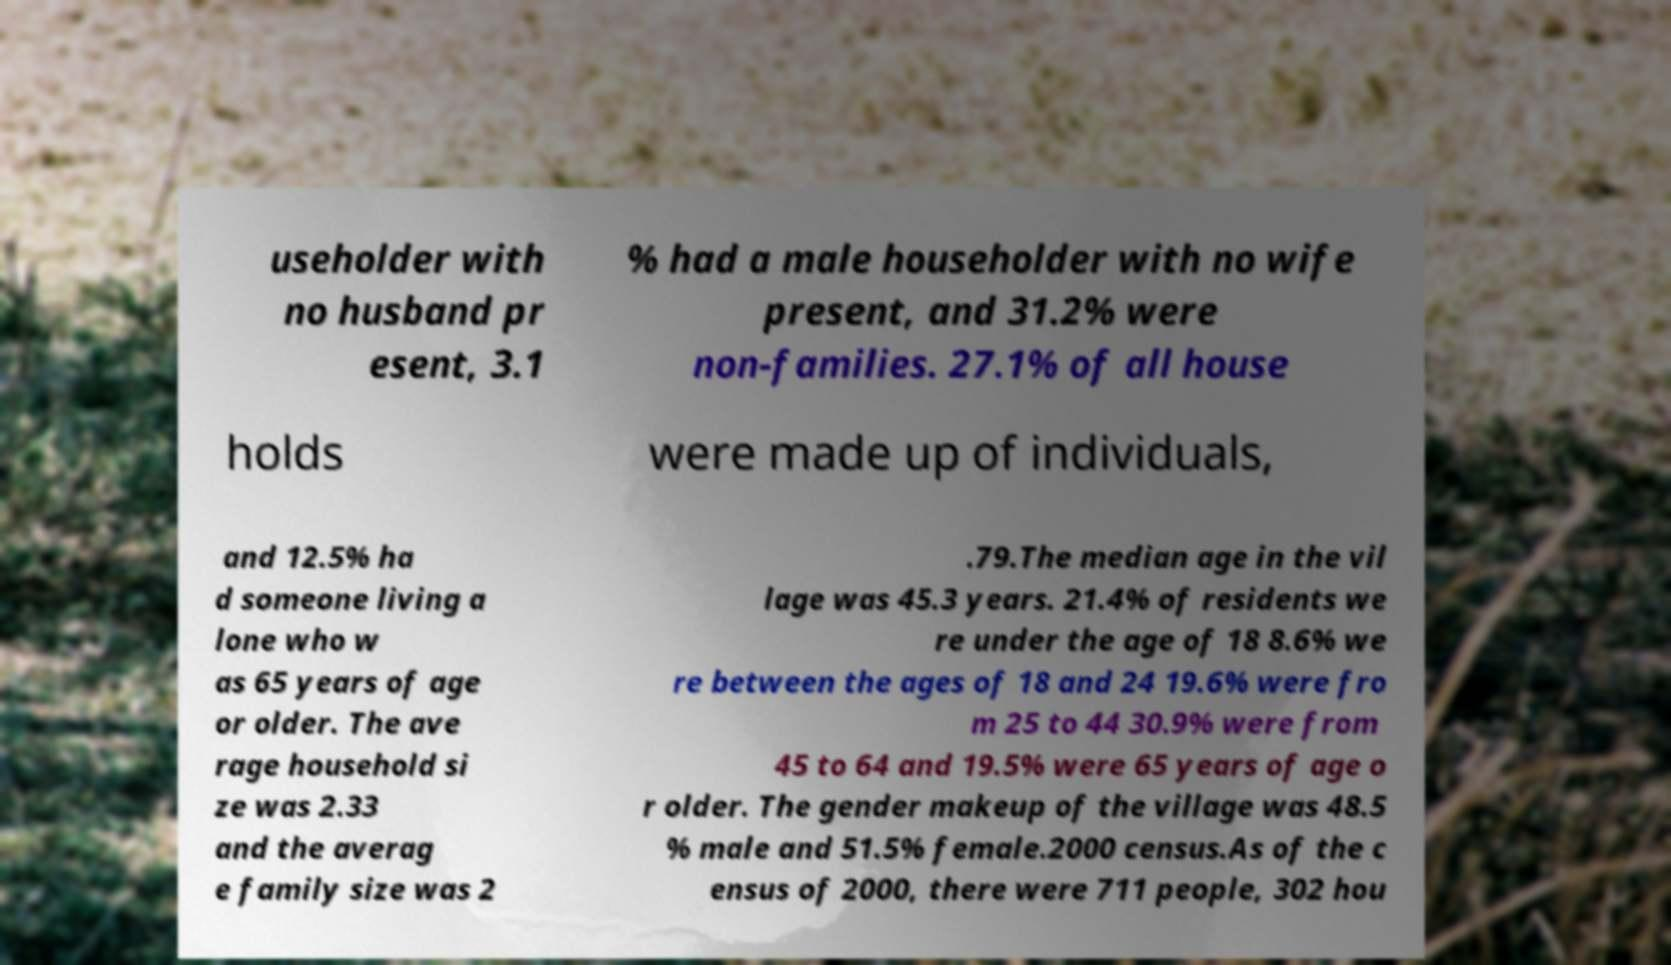Please identify and transcribe the text found in this image. useholder with no husband pr esent, 3.1 % had a male householder with no wife present, and 31.2% were non-families. 27.1% of all house holds were made up of individuals, and 12.5% ha d someone living a lone who w as 65 years of age or older. The ave rage household si ze was 2.33 and the averag e family size was 2 .79.The median age in the vil lage was 45.3 years. 21.4% of residents we re under the age of 18 8.6% we re between the ages of 18 and 24 19.6% were fro m 25 to 44 30.9% were from 45 to 64 and 19.5% were 65 years of age o r older. The gender makeup of the village was 48.5 % male and 51.5% female.2000 census.As of the c ensus of 2000, there were 711 people, 302 hou 